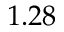<formula> <loc_0><loc_0><loc_500><loc_500>1 . 2 8</formula> 